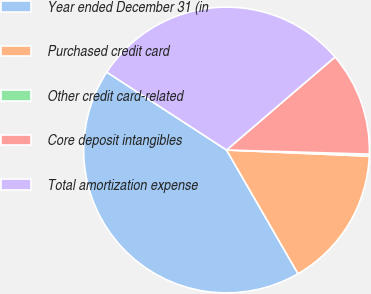Convert chart to OTSL. <chart><loc_0><loc_0><loc_500><loc_500><pie_chart><fcel>Year ended December 31 (in<fcel>Purchased credit card<fcel>Other credit card-related<fcel>Core deposit intangibles<fcel>Total amortization expense<nl><fcel>42.52%<fcel>15.97%<fcel>0.23%<fcel>11.74%<fcel>29.54%<nl></chart> 